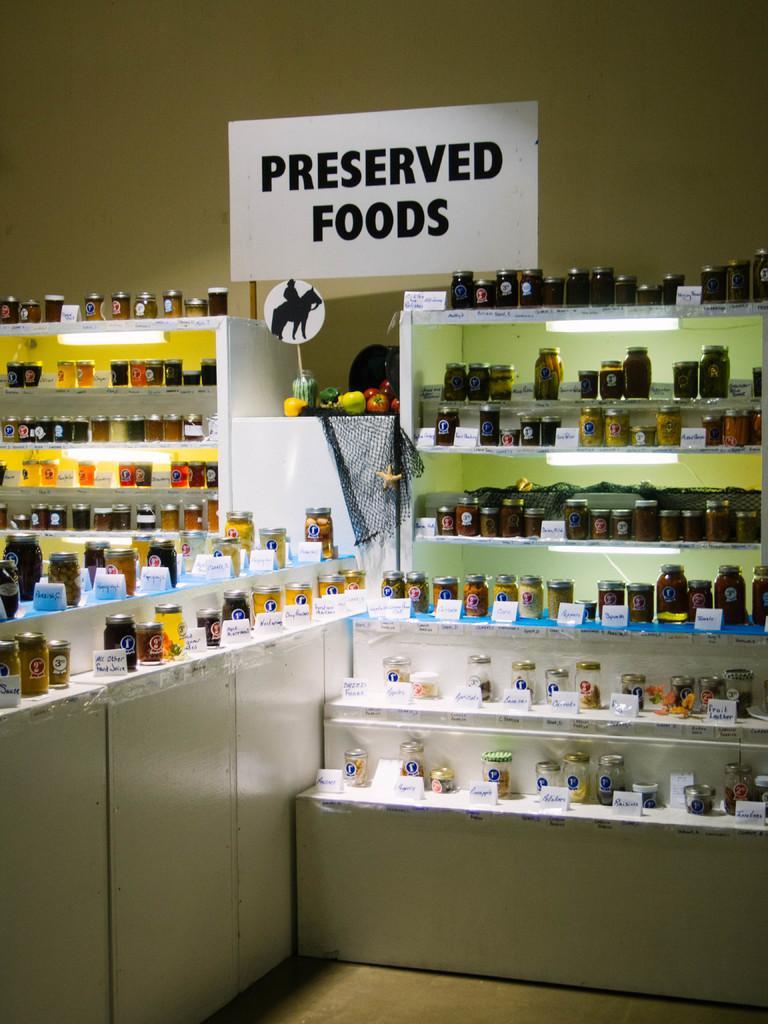Describe this image in one or two sentences. In the picture I can see bottles and some other things on shelves. I can also see a white color board which has something written on it. In the background I can see a wall. 